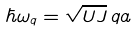<formula> <loc_0><loc_0><loc_500><loc_500>\hbar { \omega } _ { q } = \sqrt { U J } \, q a</formula> 